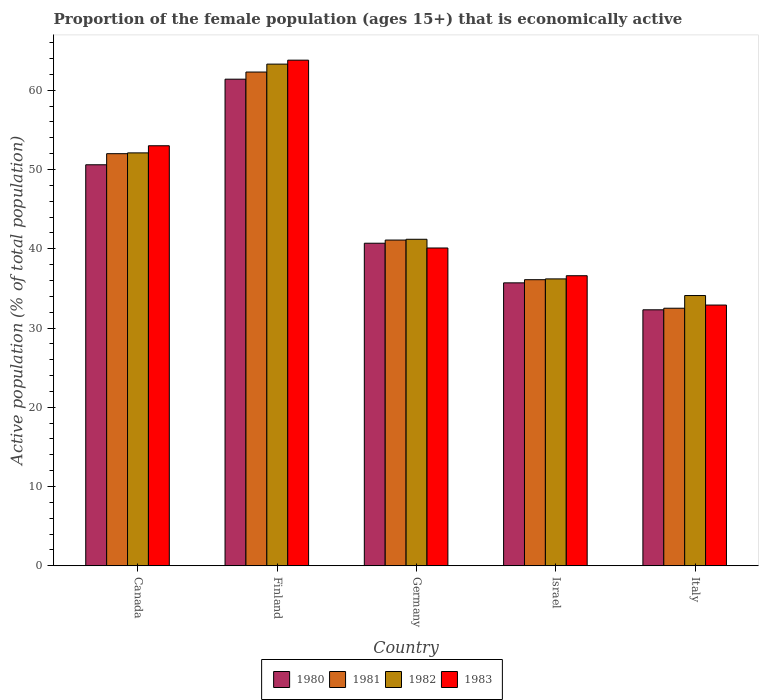How many different coloured bars are there?
Ensure brevity in your answer.  4. How many bars are there on the 4th tick from the left?
Your response must be concise. 4. How many bars are there on the 4th tick from the right?
Give a very brief answer. 4. In how many cases, is the number of bars for a given country not equal to the number of legend labels?
Make the answer very short. 0. What is the proportion of the female population that is economically active in 1980 in Finland?
Offer a terse response. 61.4. Across all countries, what is the maximum proportion of the female population that is economically active in 1982?
Provide a succinct answer. 63.3. Across all countries, what is the minimum proportion of the female population that is economically active in 1980?
Provide a short and direct response. 32.3. In which country was the proportion of the female population that is economically active in 1981 minimum?
Provide a succinct answer. Italy. What is the total proportion of the female population that is economically active in 1982 in the graph?
Your answer should be very brief. 226.9. What is the difference between the proportion of the female population that is economically active in 1982 in Canada and that in Germany?
Keep it short and to the point. 10.9. What is the difference between the proportion of the female population that is economically active in 1980 in Canada and the proportion of the female population that is economically active in 1981 in Germany?
Ensure brevity in your answer.  9.5. What is the average proportion of the female population that is economically active in 1981 per country?
Ensure brevity in your answer.  44.8. What is the difference between the proportion of the female population that is economically active of/in 1981 and proportion of the female population that is economically active of/in 1982 in Israel?
Offer a very short reply. -0.1. In how many countries, is the proportion of the female population that is economically active in 1980 greater than 22 %?
Your answer should be compact. 5. What is the ratio of the proportion of the female population that is economically active in 1981 in Finland to that in Italy?
Offer a terse response. 1.92. What is the difference between the highest and the second highest proportion of the female population that is economically active in 1983?
Ensure brevity in your answer.  -12.9. What is the difference between the highest and the lowest proportion of the female population that is economically active in 1980?
Ensure brevity in your answer.  29.1. In how many countries, is the proportion of the female population that is economically active in 1982 greater than the average proportion of the female population that is economically active in 1982 taken over all countries?
Offer a terse response. 2. Is the sum of the proportion of the female population that is economically active in 1980 in Finland and Italy greater than the maximum proportion of the female population that is economically active in 1981 across all countries?
Give a very brief answer. Yes. Is it the case that in every country, the sum of the proportion of the female population that is economically active in 1980 and proportion of the female population that is economically active in 1981 is greater than the sum of proportion of the female population that is economically active in 1983 and proportion of the female population that is economically active in 1982?
Give a very brief answer. No. What does the 1st bar from the left in Germany represents?
Your response must be concise. 1980. What does the 2nd bar from the right in Canada represents?
Make the answer very short. 1982. Is it the case that in every country, the sum of the proportion of the female population that is economically active in 1982 and proportion of the female population that is economically active in 1981 is greater than the proportion of the female population that is economically active in 1983?
Give a very brief answer. Yes. How many bars are there?
Your answer should be compact. 20. Are all the bars in the graph horizontal?
Provide a short and direct response. No. How many countries are there in the graph?
Your answer should be very brief. 5. Does the graph contain any zero values?
Give a very brief answer. No. How are the legend labels stacked?
Offer a very short reply. Horizontal. What is the title of the graph?
Make the answer very short. Proportion of the female population (ages 15+) that is economically active. Does "1978" appear as one of the legend labels in the graph?
Make the answer very short. No. What is the label or title of the Y-axis?
Offer a terse response. Active population (% of total population). What is the Active population (% of total population) of 1980 in Canada?
Offer a terse response. 50.6. What is the Active population (% of total population) of 1982 in Canada?
Provide a short and direct response. 52.1. What is the Active population (% of total population) of 1980 in Finland?
Ensure brevity in your answer.  61.4. What is the Active population (% of total population) in 1981 in Finland?
Your response must be concise. 62.3. What is the Active population (% of total population) in 1982 in Finland?
Provide a short and direct response. 63.3. What is the Active population (% of total population) of 1983 in Finland?
Ensure brevity in your answer.  63.8. What is the Active population (% of total population) in 1980 in Germany?
Offer a terse response. 40.7. What is the Active population (% of total population) in 1981 in Germany?
Provide a short and direct response. 41.1. What is the Active population (% of total population) of 1982 in Germany?
Your answer should be compact. 41.2. What is the Active population (% of total population) of 1983 in Germany?
Offer a very short reply. 40.1. What is the Active population (% of total population) in 1980 in Israel?
Your response must be concise. 35.7. What is the Active population (% of total population) in 1981 in Israel?
Give a very brief answer. 36.1. What is the Active population (% of total population) in 1982 in Israel?
Provide a short and direct response. 36.2. What is the Active population (% of total population) of 1983 in Israel?
Provide a succinct answer. 36.6. What is the Active population (% of total population) of 1980 in Italy?
Provide a succinct answer. 32.3. What is the Active population (% of total population) of 1981 in Italy?
Keep it short and to the point. 32.5. What is the Active population (% of total population) of 1982 in Italy?
Offer a terse response. 34.1. What is the Active population (% of total population) in 1983 in Italy?
Ensure brevity in your answer.  32.9. Across all countries, what is the maximum Active population (% of total population) in 1980?
Keep it short and to the point. 61.4. Across all countries, what is the maximum Active population (% of total population) of 1981?
Provide a succinct answer. 62.3. Across all countries, what is the maximum Active population (% of total population) in 1982?
Give a very brief answer. 63.3. Across all countries, what is the maximum Active population (% of total population) of 1983?
Give a very brief answer. 63.8. Across all countries, what is the minimum Active population (% of total population) in 1980?
Keep it short and to the point. 32.3. Across all countries, what is the minimum Active population (% of total population) of 1981?
Your response must be concise. 32.5. Across all countries, what is the minimum Active population (% of total population) of 1982?
Your response must be concise. 34.1. Across all countries, what is the minimum Active population (% of total population) of 1983?
Give a very brief answer. 32.9. What is the total Active population (% of total population) in 1980 in the graph?
Offer a terse response. 220.7. What is the total Active population (% of total population) of 1981 in the graph?
Ensure brevity in your answer.  224. What is the total Active population (% of total population) in 1982 in the graph?
Offer a terse response. 226.9. What is the total Active population (% of total population) in 1983 in the graph?
Your answer should be compact. 226.4. What is the difference between the Active population (% of total population) of 1980 in Canada and that in Finland?
Offer a very short reply. -10.8. What is the difference between the Active population (% of total population) of 1981 in Canada and that in Finland?
Your answer should be compact. -10.3. What is the difference between the Active population (% of total population) of 1983 in Canada and that in Finland?
Give a very brief answer. -10.8. What is the difference between the Active population (% of total population) in 1980 in Canada and that in Germany?
Offer a very short reply. 9.9. What is the difference between the Active population (% of total population) of 1982 in Canada and that in Germany?
Ensure brevity in your answer.  10.9. What is the difference between the Active population (% of total population) of 1980 in Canada and that in Israel?
Ensure brevity in your answer.  14.9. What is the difference between the Active population (% of total population) of 1981 in Canada and that in Israel?
Offer a terse response. 15.9. What is the difference between the Active population (% of total population) of 1982 in Canada and that in Israel?
Give a very brief answer. 15.9. What is the difference between the Active population (% of total population) in 1980 in Canada and that in Italy?
Ensure brevity in your answer.  18.3. What is the difference between the Active population (% of total population) of 1983 in Canada and that in Italy?
Make the answer very short. 20.1. What is the difference between the Active population (% of total population) in 1980 in Finland and that in Germany?
Offer a terse response. 20.7. What is the difference between the Active population (% of total population) in 1981 in Finland and that in Germany?
Your answer should be very brief. 21.2. What is the difference between the Active population (% of total population) of 1982 in Finland and that in Germany?
Offer a terse response. 22.1. What is the difference between the Active population (% of total population) of 1983 in Finland and that in Germany?
Your response must be concise. 23.7. What is the difference between the Active population (% of total population) of 1980 in Finland and that in Israel?
Keep it short and to the point. 25.7. What is the difference between the Active population (% of total population) of 1981 in Finland and that in Israel?
Provide a short and direct response. 26.2. What is the difference between the Active population (% of total population) in 1982 in Finland and that in Israel?
Your answer should be compact. 27.1. What is the difference between the Active population (% of total population) in 1983 in Finland and that in Israel?
Your answer should be compact. 27.2. What is the difference between the Active population (% of total population) of 1980 in Finland and that in Italy?
Make the answer very short. 29.1. What is the difference between the Active population (% of total population) of 1981 in Finland and that in Italy?
Make the answer very short. 29.8. What is the difference between the Active population (% of total population) in 1982 in Finland and that in Italy?
Provide a succinct answer. 29.2. What is the difference between the Active population (% of total population) in 1983 in Finland and that in Italy?
Offer a very short reply. 30.9. What is the difference between the Active population (% of total population) in 1980 in Germany and that in Israel?
Your answer should be compact. 5. What is the difference between the Active population (% of total population) in 1981 in Germany and that in Israel?
Give a very brief answer. 5. What is the difference between the Active population (% of total population) in 1980 in Germany and that in Italy?
Offer a terse response. 8.4. What is the difference between the Active population (% of total population) in 1982 in Germany and that in Italy?
Provide a short and direct response. 7.1. What is the difference between the Active population (% of total population) in 1983 in Germany and that in Italy?
Make the answer very short. 7.2. What is the difference between the Active population (% of total population) in 1981 in Israel and that in Italy?
Provide a succinct answer. 3.6. What is the difference between the Active population (% of total population) in 1982 in Israel and that in Italy?
Make the answer very short. 2.1. What is the difference between the Active population (% of total population) of 1983 in Israel and that in Italy?
Offer a terse response. 3.7. What is the difference between the Active population (% of total population) in 1980 in Canada and the Active population (% of total population) in 1981 in Finland?
Provide a short and direct response. -11.7. What is the difference between the Active population (% of total population) in 1980 in Canada and the Active population (% of total population) in 1982 in Finland?
Offer a terse response. -12.7. What is the difference between the Active population (% of total population) of 1980 in Canada and the Active population (% of total population) of 1983 in Finland?
Keep it short and to the point. -13.2. What is the difference between the Active population (% of total population) in 1981 in Canada and the Active population (% of total population) in 1983 in Finland?
Keep it short and to the point. -11.8. What is the difference between the Active population (% of total population) in 1980 in Canada and the Active population (% of total population) in 1981 in Germany?
Offer a very short reply. 9.5. What is the difference between the Active population (% of total population) in 1981 in Canada and the Active population (% of total population) in 1982 in Germany?
Your response must be concise. 10.8. What is the difference between the Active population (% of total population) of 1982 in Canada and the Active population (% of total population) of 1983 in Germany?
Ensure brevity in your answer.  12. What is the difference between the Active population (% of total population) in 1980 in Canada and the Active population (% of total population) in 1981 in Israel?
Provide a short and direct response. 14.5. What is the difference between the Active population (% of total population) of 1980 in Canada and the Active population (% of total population) of 1983 in Israel?
Your answer should be compact. 14. What is the difference between the Active population (% of total population) in 1981 in Canada and the Active population (% of total population) in 1982 in Israel?
Offer a very short reply. 15.8. What is the difference between the Active population (% of total population) of 1982 in Canada and the Active population (% of total population) of 1983 in Israel?
Offer a terse response. 15.5. What is the difference between the Active population (% of total population) in 1981 in Canada and the Active population (% of total population) in 1983 in Italy?
Keep it short and to the point. 19.1. What is the difference between the Active population (% of total population) of 1982 in Canada and the Active population (% of total population) of 1983 in Italy?
Ensure brevity in your answer.  19.2. What is the difference between the Active population (% of total population) of 1980 in Finland and the Active population (% of total population) of 1981 in Germany?
Ensure brevity in your answer.  20.3. What is the difference between the Active population (% of total population) of 1980 in Finland and the Active population (% of total population) of 1982 in Germany?
Your response must be concise. 20.2. What is the difference between the Active population (% of total population) of 1980 in Finland and the Active population (% of total population) of 1983 in Germany?
Provide a succinct answer. 21.3. What is the difference between the Active population (% of total population) of 1981 in Finland and the Active population (% of total population) of 1982 in Germany?
Provide a short and direct response. 21.1. What is the difference between the Active population (% of total population) of 1981 in Finland and the Active population (% of total population) of 1983 in Germany?
Your answer should be compact. 22.2. What is the difference between the Active population (% of total population) of 1982 in Finland and the Active population (% of total population) of 1983 in Germany?
Ensure brevity in your answer.  23.2. What is the difference between the Active population (% of total population) of 1980 in Finland and the Active population (% of total population) of 1981 in Israel?
Offer a terse response. 25.3. What is the difference between the Active population (% of total population) in 1980 in Finland and the Active population (% of total population) in 1982 in Israel?
Offer a terse response. 25.2. What is the difference between the Active population (% of total population) in 1980 in Finland and the Active population (% of total population) in 1983 in Israel?
Ensure brevity in your answer.  24.8. What is the difference between the Active population (% of total population) of 1981 in Finland and the Active population (% of total population) of 1982 in Israel?
Your answer should be compact. 26.1. What is the difference between the Active population (% of total population) in 1981 in Finland and the Active population (% of total population) in 1983 in Israel?
Provide a succinct answer. 25.7. What is the difference between the Active population (% of total population) of 1982 in Finland and the Active population (% of total population) of 1983 in Israel?
Your answer should be very brief. 26.7. What is the difference between the Active population (% of total population) in 1980 in Finland and the Active population (% of total population) in 1981 in Italy?
Provide a succinct answer. 28.9. What is the difference between the Active population (% of total population) in 1980 in Finland and the Active population (% of total population) in 1982 in Italy?
Provide a succinct answer. 27.3. What is the difference between the Active population (% of total population) of 1981 in Finland and the Active population (% of total population) of 1982 in Italy?
Your answer should be compact. 28.2. What is the difference between the Active population (% of total population) in 1981 in Finland and the Active population (% of total population) in 1983 in Italy?
Make the answer very short. 29.4. What is the difference between the Active population (% of total population) of 1982 in Finland and the Active population (% of total population) of 1983 in Italy?
Ensure brevity in your answer.  30.4. What is the difference between the Active population (% of total population) in 1980 in Germany and the Active population (% of total population) in 1982 in Israel?
Make the answer very short. 4.5. What is the difference between the Active population (% of total population) in 1980 in Germany and the Active population (% of total population) in 1983 in Israel?
Make the answer very short. 4.1. What is the difference between the Active population (% of total population) of 1981 in Germany and the Active population (% of total population) of 1982 in Israel?
Provide a succinct answer. 4.9. What is the difference between the Active population (% of total population) in 1980 in Germany and the Active population (% of total population) in 1982 in Italy?
Give a very brief answer. 6.6. What is the difference between the Active population (% of total population) of 1981 in Germany and the Active population (% of total population) of 1982 in Italy?
Keep it short and to the point. 7. What is the difference between the Active population (% of total population) in 1981 in Germany and the Active population (% of total population) in 1983 in Italy?
Make the answer very short. 8.2. What is the difference between the Active population (% of total population) of 1982 in Germany and the Active population (% of total population) of 1983 in Italy?
Your answer should be compact. 8.3. What is the difference between the Active population (% of total population) in 1980 in Israel and the Active population (% of total population) in 1981 in Italy?
Ensure brevity in your answer.  3.2. What is the difference between the Active population (% of total population) of 1980 in Israel and the Active population (% of total population) of 1982 in Italy?
Keep it short and to the point. 1.6. What is the difference between the Active population (% of total population) in 1980 in Israel and the Active population (% of total population) in 1983 in Italy?
Make the answer very short. 2.8. What is the difference between the Active population (% of total population) of 1981 in Israel and the Active population (% of total population) of 1982 in Italy?
Offer a very short reply. 2. What is the difference between the Active population (% of total population) in 1982 in Israel and the Active population (% of total population) in 1983 in Italy?
Your response must be concise. 3.3. What is the average Active population (% of total population) in 1980 per country?
Keep it short and to the point. 44.14. What is the average Active population (% of total population) in 1981 per country?
Provide a succinct answer. 44.8. What is the average Active population (% of total population) in 1982 per country?
Provide a succinct answer. 45.38. What is the average Active population (% of total population) in 1983 per country?
Your response must be concise. 45.28. What is the difference between the Active population (% of total population) in 1980 and Active population (% of total population) in 1982 in Canada?
Keep it short and to the point. -1.5. What is the difference between the Active population (% of total population) in 1981 and Active population (% of total population) in 1983 in Canada?
Your answer should be very brief. -1. What is the difference between the Active population (% of total population) in 1980 and Active population (% of total population) in 1983 in Finland?
Ensure brevity in your answer.  -2.4. What is the difference between the Active population (% of total population) of 1980 and Active population (% of total population) of 1981 in Germany?
Your response must be concise. -0.4. What is the difference between the Active population (% of total population) in 1980 and Active population (% of total population) in 1982 in Germany?
Your answer should be compact. -0.5. What is the difference between the Active population (% of total population) in 1981 and Active population (% of total population) in 1983 in Germany?
Your answer should be very brief. 1. What is the difference between the Active population (% of total population) in 1980 and Active population (% of total population) in 1981 in Israel?
Make the answer very short. -0.4. What is the difference between the Active population (% of total population) of 1980 and Active population (% of total population) of 1982 in Israel?
Give a very brief answer. -0.5. What is the difference between the Active population (% of total population) of 1980 and Active population (% of total population) of 1983 in Israel?
Your response must be concise. -0.9. What is the difference between the Active population (% of total population) of 1980 and Active population (% of total population) of 1981 in Italy?
Offer a very short reply. -0.2. What is the difference between the Active population (% of total population) in 1980 and Active population (% of total population) in 1982 in Italy?
Provide a succinct answer. -1.8. What is the difference between the Active population (% of total population) of 1980 and Active population (% of total population) of 1983 in Italy?
Your answer should be compact. -0.6. What is the difference between the Active population (% of total population) in 1981 and Active population (% of total population) in 1983 in Italy?
Offer a terse response. -0.4. What is the ratio of the Active population (% of total population) in 1980 in Canada to that in Finland?
Provide a short and direct response. 0.82. What is the ratio of the Active population (% of total population) of 1981 in Canada to that in Finland?
Your response must be concise. 0.83. What is the ratio of the Active population (% of total population) in 1982 in Canada to that in Finland?
Your response must be concise. 0.82. What is the ratio of the Active population (% of total population) in 1983 in Canada to that in Finland?
Ensure brevity in your answer.  0.83. What is the ratio of the Active population (% of total population) of 1980 in Canada to that in Germany?
Offer a terse response. 1.24. What is the ratio of the Active population (% of total population) in 1981 in Canada to that in Germany?
Your answer should be compact. 1.27. What is the ratio of the Active population (% of total population) in 1982 in Canada to that in Germany?
Keep it short and to the point. 1.26. What is the ratio of the Active population (% of total population) of 1983 in Canada to that in Germany?
Your response must be concise. 1.32. What is the ratio of the Active population (% of total population) of 1980 in Canada to that in Israel?
Ensure brevity in your answer.  1.42. What is the ratio of the Active population (% of total population) in 1981 in Canada to that in Israel?
Give a very brief answer. 1.44. What is the ratio of the Active population (% of total population) in 1982 in Canada to that in Israel?
Offer a terse response. 1.44. What is the ratio of the Active population (% of total population) of 1983 in Canada to that in Israel?
Your answer should be compact. 1.45. What is the ratio of the Active population (% of total population) of 1980 in Canada to that in Italy?
Your response must be concise. 1.57. What is the ratio of the Active population (% of total population) of 1982 in Canada to that in Italy?
Offer a very short reply. 1.53. What is the ratio of the Active population (% of total population) in 1983 in Canada to that in Italy?
Give a very brief answer. 1.61. What is the ratio of the Active population (% of total population) of 1980 in Finland to that in Germany?
Keep it short and to the point. 1.51. What is the ratio of the Active population (% of total population) of 1981 in Finland to that in Germany?
Provide a short and direct response. 1.52. What is the ratio of the Active population (% of total population) in 1982 in Finland to that in Germany?
Your response must be concise. 1.54. What is the ratio of the Active population (% of total population) of 1983 in Finland to that in Germany?
Your answer should be compact. 1.59. What is the ratio of the Active population (% of total population) in 1980 in Finland to that in Israel?
Give a very brief answer. 1.72. What is the ratio of the Active population (% of total population) in 1981 in Finland to that in Israel?
Your answer should be very brief. 1.73. What is the ratio of the Active population (% of total population) of 1982 in Finland to that in Israel?
Offer a terse response. 1.75. What is the ratio of the Active population (% of total population) in 1983 in Finland to that in Israel?
Provide a short and direct response. 1.74. What is the ratio of the Active population (% of total population) of 1980 in Finland to that in Italy?
Give a very brief answer. 1.9. What is the ratio of the Active population (% of total population) of 1981 in Finland to that in Italy?
Offer a terse response. 1.92. What is the ratio of the Active population (% of total population) in 1982 in Finland to that in Italy?
Keep it short and to the point. 1.86. What is the ratio of the Active population (% of total population) of 1983 in Finland to that in Italy?
Your answer should be very brief. 1.94. What is the ratio of the Active population (% of total population) in 1980 in Germany to that in Israel?
Give a very brief answer. 1.14. What is the ratio of the Active population (% of total population) of 1981 in Germany to that in Israel?
Provide a short and direct response. 1.14. What is the ratio of the Active population (% of total population) of 1982 in Germany to that in Israel?
Provide a succinct answer. 1.14. What is the ratio of the Active population (% of total population) in 1983 in Germany to that in Israel?
Offer a terse response. 1.1. What is the ratio of the Active population (% of total population) of 1980 in Germany to that in Italy?
Keep it short and to the point. 1.26. What is the ratio of the Active population (% of total population) of 1981 in Germany to that in Italy?
Keep it short and to the point. 1.26. What is the ratio of the Active population (% of total population) of 1982 in Germany to that in Italy?
Keep it short and to the point. 1.21. What is the ratio of the Active population (% of total population) in 1983 in Germany to that in Italy?
Offer a terse response. 1.22. What is the ratio of the Active population (% of total population) of 1980 in Israel to that in Italy?
Ensure brevity in your answer.  1.11. What is the ratio of the Active population (% of total population) of 1981 in Israel to that in Italy?
Provide a short and direct response. 1.11. What is the ratio of the Active population (% of total population) in 1982 in Israel to that in Italy?
Provide a short and direct response. 1.06. What is the ratio of the Active population (% of total population) of 1983 in Israel to that in Italy?
Your answer should be very brief. 1.11. What is the difference between the highest and the second highest Active population (% of total population) in 1982?
Your answer should be compact. 11.2. What is the difference between the highest and the second highest Active population (% of total population) in 1983?
Provide a short and direct response. 10.8. What is the difference between the highest and the lowest Active population (% of total population) in 1980?
Give a very brief answer. 29.1. What is the difference between the highest and the lowest Active population (% of total population) of 1981?
Make the answer very short. 29.8. What is the difference between the highest and the lowest Active population (% of total population) in 1982?
Keep it short and to the point. 29.2. What is the difference between the highest and the lowest Active population (% of total population) of 1983?
Offer a terse response. 30.9. 